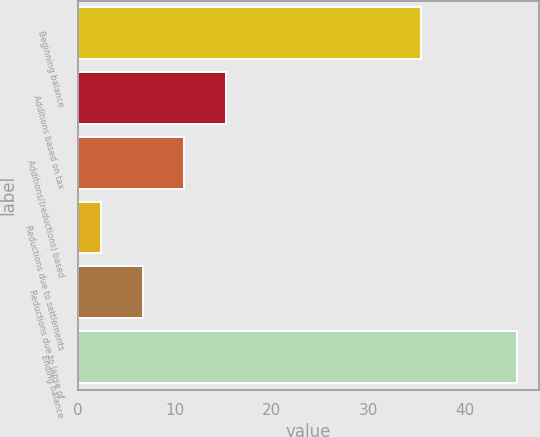<chart> <loc_0><loc_0><loc_500><loc_500><bar_chart><fcel>Beginning balance<fcel>Additions based on tax<fcel>Additions/(reductions) based<fcel>Reductions due to settlements<fcel>Reductions due to lapse of<fcel>Ending balance<nl><fcel>35.4<fcel>15.27<fcel>10.98<fcel>2.4<fcel>6.69<fcel>45.3<nl></chart> 